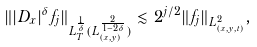Convert formula to latex. <formula><loc_0><loc_0><loc_500><loc_500>\| | D _ { x } | ^ { \delta } f _ { j } \| _ { L ^ { \frac { 1 } { \delta } } _ { T } ( L ^ { \frac { 2 } { 1 - 2 \delta } } _ { ( x , y ) } ) } \lesssim 2 ^ { j / 2 } \| f _ { j } \| _ { L ^ { 2 } _ { ( x , y , t ) } } ,</formula> 